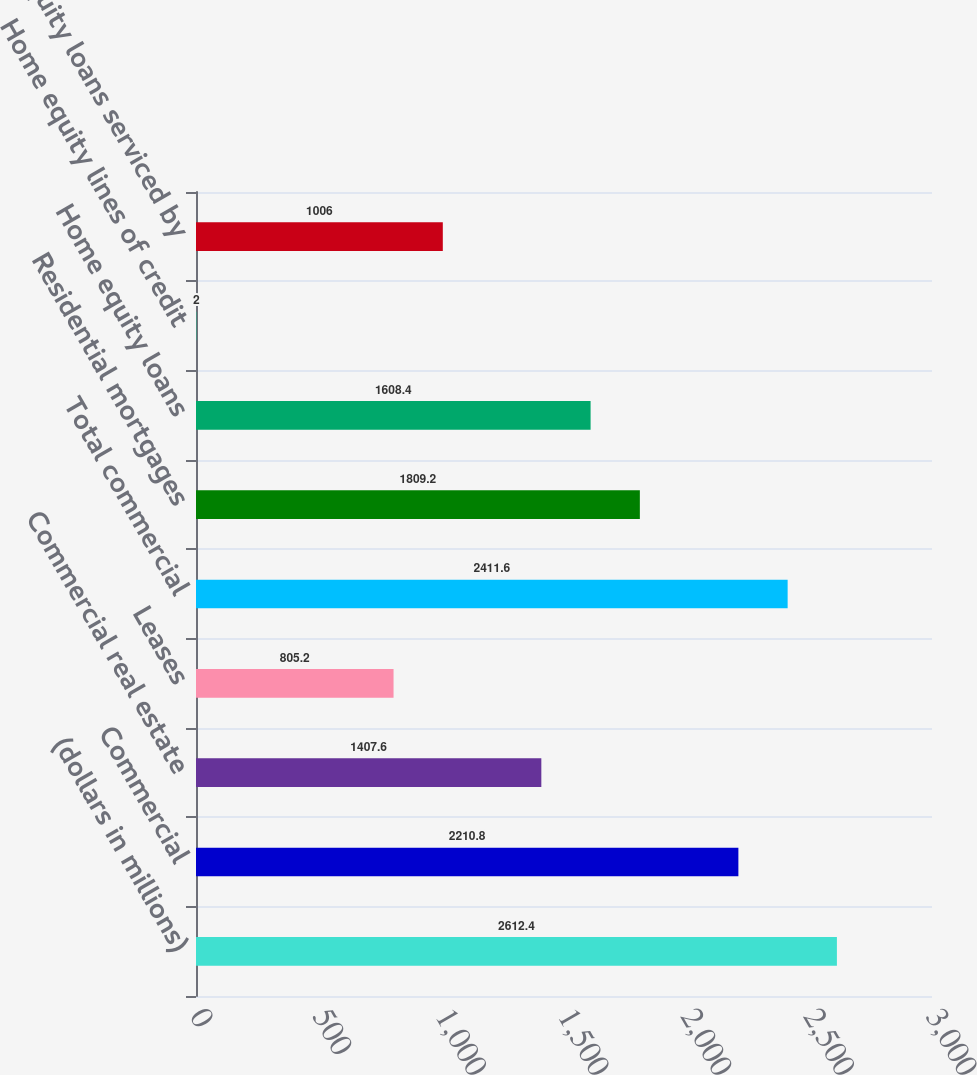Convert chart. <chart><loc_0><loc_0><loc_500><loc_500><bar_chart><fcel>(dollars in millions)<fcel>Commercial<fcel>Commercial real estate<fcel>Leases<fcel>Total commercial<fcel>Residential mortgages<fcel>Home equity loans<fcel>Home equity lines of credit<fcel>Home equity loans serviced by<nl><fcel>2612.4<fcel>2210.8<fcel>1407.6<fcel>805.2<fcel>2411.6<fcel>1809.2<fcel>1608.4<fcel>2<fcel>1006<nl></chart> 